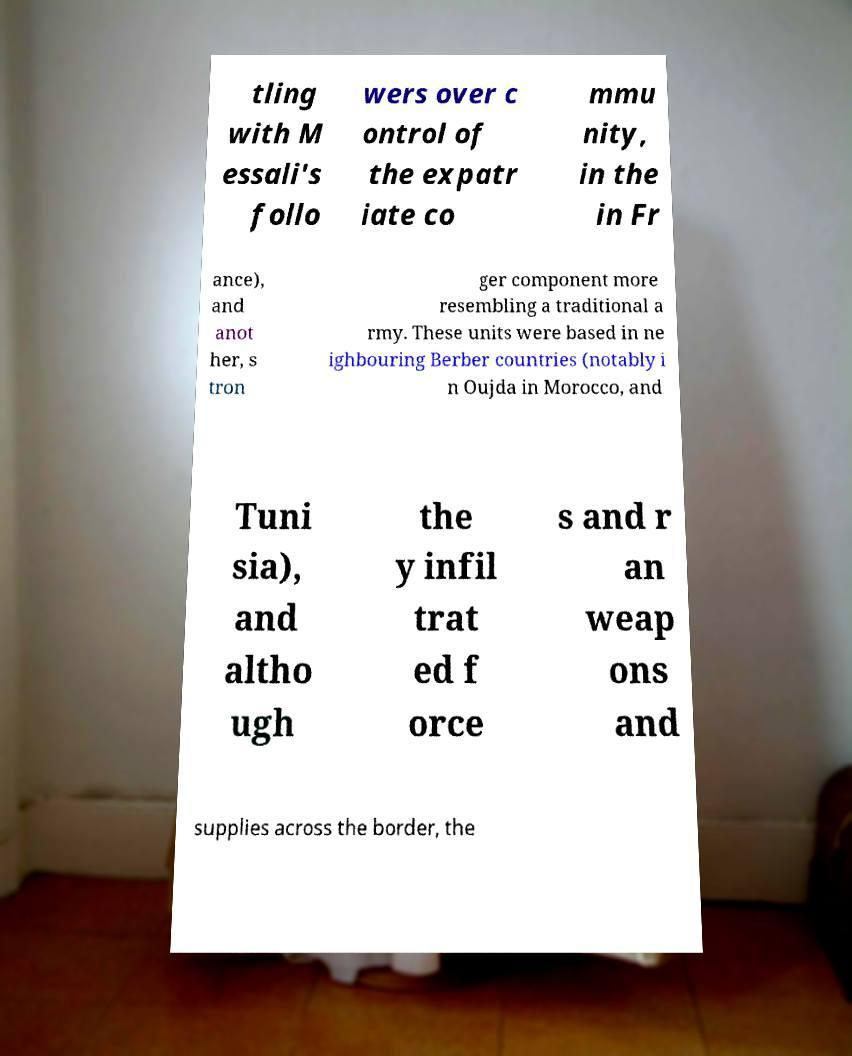Can you accurately transcribe the text from the provided image for me? tling with M essali's follo wers over c ontrol of the expatr iate co mmu nity, in the in Fr ance), and anot her, s tron ger component more resembling a traditional a rmy. These units were based in ne ighbouring Berber countries (notably i n Oujda in Morocco, and Tuni sia), and altho ugh the y infil trat ed f orce s and r an weap ons and supplies across the border, the 